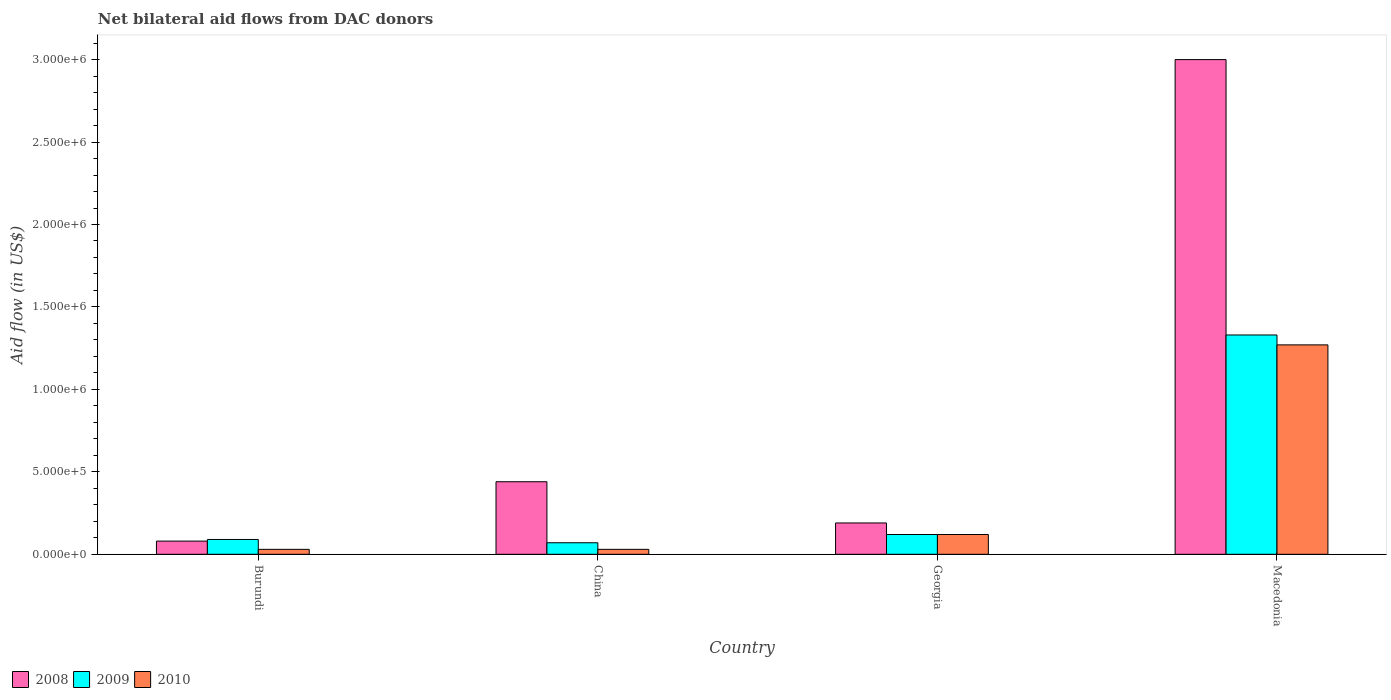How many different coloured bars are there?
Offer a terse response. 3. Are the number of bars on each tick of the X-axis equal?
Make the answer very short. Yes. What is the label of the 2nd group of bars from the left?
Offer a very short reply. China. In how many cases, is the number of bars for a given country not equal to the number of legend labels?
Ensure brevity in your answer.  0. Across all countries, what is the maximum net bilateral aid flow in 2009?
Offer a terse response. 1.33e+06. In which country was the net bilateral aid flow in 2008 maximum?
Your answer should be compact. Macedonia. In which country was the net bilateral aid flow in 2008 minimum?
Your answer should be very brief. Burundi. What is the total net bilateral aid flow in 2009 in the graph?
Provide a short and direct response. 1.61e+06. What is the difference between the net bilateral aid flow in 2010 in Burundi and the net bilateral aid flow in 2009 in Macedonia?
Ensure brevity in your answer.  -1.30e+06. What is the average net bilateral aid flow in 2009 per country?
Offer a very short reply. 4.02e+05. In how many countries, is the net bilateral aid flow in 2009 greater than 2600000 US$?
Give a very brief answer. 0. Is the difference between the net bilateral aid flow in 2010 in Georgia and Macedonia greater than the difference between the net bilateral aid flow in 2008 in Georgia and Macedonia?
Provide a short and direct response. Yes. What is the difference between the highest and the second highest net bilateral aid flow in 2008?
Your answer should be compact. 2.81e+06. What is the difference between the highest and the lowest net bilateral aid flow in 2010?
Provide a short and direct response. 1.24e+06. Is the sum of the net bilateral aid flow in 2010 in Burundi and Macedonia greater than the maximum net bilateral aid flow in 2009 across all countries?
Your answer should be compact. No. How many bars are there?
Your answer should be compact. 12. Are all the bars in the graph horizontal?
Make the answer very short. No. Does the graph contain any zero values?
Provide a succinct answer. No. Where does the legend appear in the graph?
Offer a very short reply. Bottom left. How are the legend labels stacked?
Your answer should be very brief. Horizontal. What is the title of the graph?
Your answer should be very brief. Net bilateral aid flows from DAC donors. What is the label or title of the X-axis?
Keep it short and to the point. Country. What is the label or title of the Y-axis?
Your answer should be compact. Aid flow (in US$). What is the Aid flow (in US$) in 2008 in Burundi?
Provide a succinct answer. 8.00e+04. What is the Aid flow (in US$) of 2010 in Burundi?
Provide a short and direct response. 3.00e+04. What is the Aid flow (in US$) in 2008 in Macedonia?
Offer a very short reply. 3.00e+06. What is the Aid flow (in US$) in 2009 in Macedonia?
Offer a terse response. 1.33e+06. What is the Aid flow (in US$) in 2010 in Macedonia?
Provide a succinct answer. 1.27e+06. Across all countries, what is the maximum Aid flow (in US$) of 2008?
Provide a short and direct response. 3.00e+06. Across all countries, what is the maximum Aid flow (in US$) in 2009?
Your answer should be very brief. 1.33e+06. Across all countries, what is the maximum Aid flow (in US$) of 2010?
Your answer should be very brief. 1.27e+06. Across all countries, what is the minimum Aid flow (in US$) of 2008?
Provide a succinct answer. 8.00e+04. What is the total Aid flow (in US$) of 2008 in the graph?
Keep it short and to the point. 3.71e+06. What is the total Aid flow (in US$) in 2009 in the graph?
Offer a very short reply. 1.61e+06. What is the total Aid flow (in US$) of 2010 in the graph?
Give a very brief answer. 1.45e+06. What is the difference between the Aid flow (in US$) of 2008 in Burundi and that in China?
Your answer should be very brief. -3.60e+05. What is the difference between the Aid flow (in US$) in 2009 in Burundi and that in China?
Give a very brief answer. 2.00e+04. What is the difference between the Aid flow (in US$) in 2008 in Burundi and that in Georgia?
Offer a very short reply. -1.10e+05. What is the difference between the Aid flow (in US$) of 2010 in Burundi and that in Georgia?
Offer a very short reply. -9.00e+04. What is the difference between the Aid flow (in US$) in 2008 in Burundi and that in Macedonia?
Make the answer very short. -2.92e+06. What is the difference between the Aid flow (in US$) of 2009 in Burundi and that in Macedonia?
Your answer should be very brief. -1.24e+06. What is the difference between the Aid flow (in US$) of 2010 in Burundi and that in Macedonia?
Provide a short and direct response. -1.24e+06. What is the difference between the Aid flow (in US$) in 2008 in China and that in Georgia?
Ensure brevity in your answer.  2.50e+05. What is the difference between the Aid flow (in US$) in 2008 in China and that in Macedonia?
Your response must be concise. -2.56e+06. What is the difference between the Aid flow (in US$) of 2009 in China and that in Macedonia?
Ensure brevity in your answer.  -1.26e+06. What is the difference between the Aid flow (in US$) in 2010 in China and that in Macedonia?
Give a very brief answer. -1.24e+06. What is the difference between the Aid flow (in US$) in 2008 in Georgia and that in Macedonia?
Your answer should be very brief. -2.81e+06. What is the difference between the Aid flow (in US$) of 2009 in Georgia and that in Macedonia?
Keep it short and to the point. -1.21e+06. What is the difference between the Aid flow (in US$) of 2010 in Georgia and that in Macedonia?
Your answer should be compact. -1.15e+06. What is the difference between the Aid flow (in US$) of 2008 in Burundi and the Aid flow (in US$) of 2009 in China?
Keep it short and to the point. 10000. What is the difference between the Aid flow (in US$) of 2009 in Burundi and the Aid flow (in US$) of 2010 in China?
Provide a short and direct response. 6.00e+04. What is the difference between the Aid flow (in US$) in 2008 in Burundi and the Aid flow (in US$) in 2009 in Macedonia?
Your response must be concise. -1.25e+06. What is the difference between the Aid flow (in US$) of 2008 in Burundi and the Aid flow (in US$) of 2010 in Macedonia?
Provide a succinct answer. -1.19e+06. What is the difference between the Aid flow (in US$) of 2009 in Burundi and the Aid flow (in US$) of 2010 in Macedonia?
Your response must be concise. -1.18e+06. What is the difference between the Aid flow (in US$) in 2008 in China and the Aid flow (in US$) in 2009 in Georgia?
Your response must be concise. 3.20e+05. What is the difference between the Aid flow (in US$) of 2008 in China and the Aid flow (in US$) of 2010 in Georgia?
Your response must be concise. 3.20e+05. What is the difference between the Aid flow (in US$) in 2009 in China and the Aid flow (in US$) in 2010 in Georgia?
Offer a very short reply. -5.00e+04. What is the difference between the Aid flow (in US$) in 2008 in China and the Aid flow (in US$) in 2009 in Macedonia?
Give a very brief answer. -8.90e+05. What is the difference between the Aid flow (in US$) in 2008 in China and the Aid flow (in US$) in 2010 in Macedonia?
Make the answer very short. -8.30e+05. What is the difference between the Aid flow (in US$) in 2009 in China and the Aid flow (in US$) in 2010 in Macedonia?
Provide a succinct answer. -1.20e+06. What is the difference between the Aid flow (in US$) of 2008 in Georgia and the Aid flow (in US$) of 2009 in Macedonia?
Offer a very short reply. -1.14e+06. What is the difference between the Aid flow (in US$) of 2008 in Georgia and the Aid flow (in US$) of 2010 in Macedonia?
Make the answer very short. -1.08e+06. What is the difference between the Aid flow (in US$) in 2009 in Georgia and the Aid flow (in US$) in 2010 in Macedonia?
Make the answer very short. -1.15e+06. What is the average Aid flow (in US$) of 2008 per country?
Your answer should be very brief. 9.28e+05. What is the average Aid flow (in US$) of 2009 per country?
Offer a terse response. 4.02e+05. What is the average Aid flow (in US$) in 2010 per country?
Your answer should be compact. 3.62e+05. What is the difference between the Aid flow (in US$) in 2008 and Aid flow (in US$) in 2009 in Burundi?
Keep it short and to the point. -10000. What is the difference between the Aid flow (in US$) in 2008 and Aid flow (in US$) in 2010 in Burundi?
Your answer should be very brief. 5.00e+04. What is the difference between the Aid flow (in US$) of 2009 and Aid flow (in US$) of 2010 in Burundi?
Provide a short and direct response. 6.00e+04. What is the difference between the Aid flow (in US$) of 2008 and Aid flow (in US$) of 2009 in China?
Offer a terse response. 3.70e+05. What is the difference between the Aid flow (in US$) in 2009 and Aid flow (in US$) in 2010 in China?
Keep it short and to the point. 4.00e+04. What is the difference between the Aid flow (in US$) in 2008 and Aid flow (in US$) in 2009 in Georgia?
Keep it short and to the point. 7.00e+04. What is the difference between the Aid flow (in US$) of 2008 and Aid flow (in US$) of 2010 in Georgia?
Your answer should be compact. 7.00e+04. What is the difference between the Aid flow (in US$) in 2008 and Aid flow (in US$) in 2009 in Macedonia?
Provide a succinct answer. 1.67e+06. What is the difference between the Aid flow (in US$) of 2008 and Aid flow (in US$) of 2010 in Macedonia?
Provide a succinct answer. 1.73e+06. What is the ratio of the Aid flow (in US$) of 2008 in Burundi to that in China?
Your answer should be compact. 0.18. What is the ratio of the Aid flow (in US$) of 2010 in Burundi to that in China?
Make the answer very short. 1. What is the ratio of the Aid flow (in US$) of 2008 in Burundi to that in Georgia?
Your answer should be very brief. 0.42. What is the ratio of the Aid flow (in US$) in 2009 in Burundi to that in Georgia?
Your answer should be compact. 0.75. What is the ratio of the Aid flow (in US$) of 2008 in Burundi to that in Macedonia?
Provide a short and direct response. 0.03. What is the ratio of the Aid flow (in US$) in 2009 in Burundi to that in Macedonia?
Keep it short and to the point. 0.07. What is the ratio of the Aid flow (in US$) of 2010 in Burundi to that in Macedonia?
Offer a terse response. 0.02. What is the ratio of the Aid flow (in US$) in 2008 in China to that in Georgia?
Offer a terse response. 2.32. What is the ratio of the Aid flow (in US$) in 2009 in China to that in Georgia?
Make the answer very short. 0.58. What is the ratio of the Aid flow (in US$) of 2010 in China to that in Georgia?
Provide a succinct answer. 0.25. What is the ratio of the Aid flow (in US$) of 2008 in China to that in Macedonia?
Give a very brief answer. 0.15. What is the ratio of the Aid flow (in US$) of 2009 in China to that in Macedonia?
Provide a short and direct response. 0.05. What is the ratio of the Aid flow (in US$) of 2010 in China to that in Macedonia?
Your answer should be very brief. 0.02. What is the ratio of the Aid flow (in US$) in 2008 in Georgia to that in Macedonia?
Provide a short and direct response. 0.06. What is the ratio of the Aid flow (in US$) in 2009 in Georgia to that in Macedonia?
Your response must be concise. 0.09. What is the ratio of the Aid flow (in US$) in 2010 in Georgia to that in Macedonia?
Your answer should be very brief. 0.09. What is the difference between the highest and the second highest Aid flow (in US$) of 2008?
Your answer should be compact. 2.56e+06. What is the difference between the highest and the second highest Aid flow (in US$) in 2009?
Ensure brevity in your answer.  1.21e+06. What is the difference between the highest and the second highest Aid flow (in US$) in 2010?
Provide a short and direct response. 1.15e+06. What is the difference between the highest and the lowest Aid flow (in US$) of 2008?
Offer a very short reply. 2.92e+06. What is the difference between the highest and the lowest Aid flow (in US$) of 2009?
Your answer should be compact. 1.26e+06. What is the difference between the highest and the lowest Aid flow (in US$) in 2010?
Ensure brevity in your answer.  1.24e+06. 